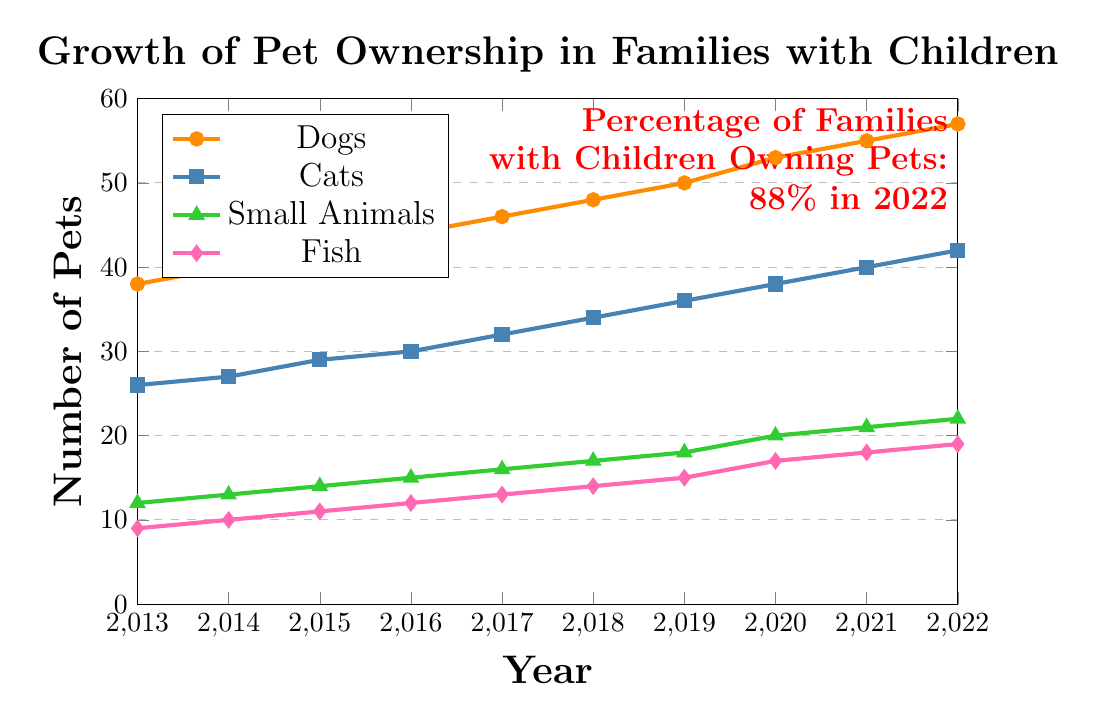What was the percentage of families with children owning pets in 2017? Look at the node on one of the lines for the year 2017 and then check the annotation indicating 72% of families with children owning pets in that year.
Answer: 72% Which type of pet had the largest increase in ownership from 2016 to 2018? Check the coordinates for each pet type in 2016 and 2018 and calculate the difference in ownership. The differences are: Dogs (48-44 = 4), Cats (34-30 = 4), Small Animals (17-15 = 2), and Fish (14-12 = 2). Both dogs and cats had the largest increase.
Answer: Dogs and Cats How many dogs were owned in 2020? Look at the coordinate for dogs in 2020 where the Y-axis value is 53.
Answer: 53 Compare the ownership of small animals and fish in 2019. Which was higher? From the data, the ownership of small animals was 18 and fish were 15 in 2019. The node for small animals is higher than the fish.
Answer: Small Animals What is the trend in the average number of pets per family from 2013 to 2022? From the coordinates, the average number of pets per family increased each year from 1.8 in 2013 to 2.8 in 2022.
Answer: Increasing By how much did the percentage of families with children owning pets increase from 2013 to 2022? Subtract the percentage in 2013 from that in 2022: 88 - 62 = 26.
Answer: 26% In which year did cat ownership first reach 30%? Find the year where the cat ownership coordinate first reaches or exceeds 30%, which is 2016.
Answer: 2016 What is the difference in the number of dogs and cats owned in 2022? Subtract the number of cats from the number of dogs in 2022: 57 - 42 = 15.
Answer: 15 Which pet type had the least growth over the decade? Compare the growth from 2013 to 2022 for each pet type: Fish increased by 10 (19-9), Small Animals by 10 (22-12), Cats by 16 (42-26), and Dogs by 19 (57-38). Fish and Small Animals had the least growth, but the absolute number increase is identical.
Answer: Fish and Small Animals What was the average number of each pet type per family in 2016 if every family owned at least one pet of each type? Use the Y-axis coordinates: Dogs (44), Cats (30), Small Animals (15), Fish (12). Divide each by the total number of pets (44+30+15+12 = 101) and then by families owning pets in 2016 (69%), yielding approximately: Dogs (44/101 ≈ 0.44), Cats (30/101 ≈ 0.3), Small Animals (15/101 ≈ 0.15), Fish (12/101 ≈ 0.12).
Answer: Dogs: ~0.44, Cats: ~0.3, Small Animals: ~0.15, Fish: ~0.12 